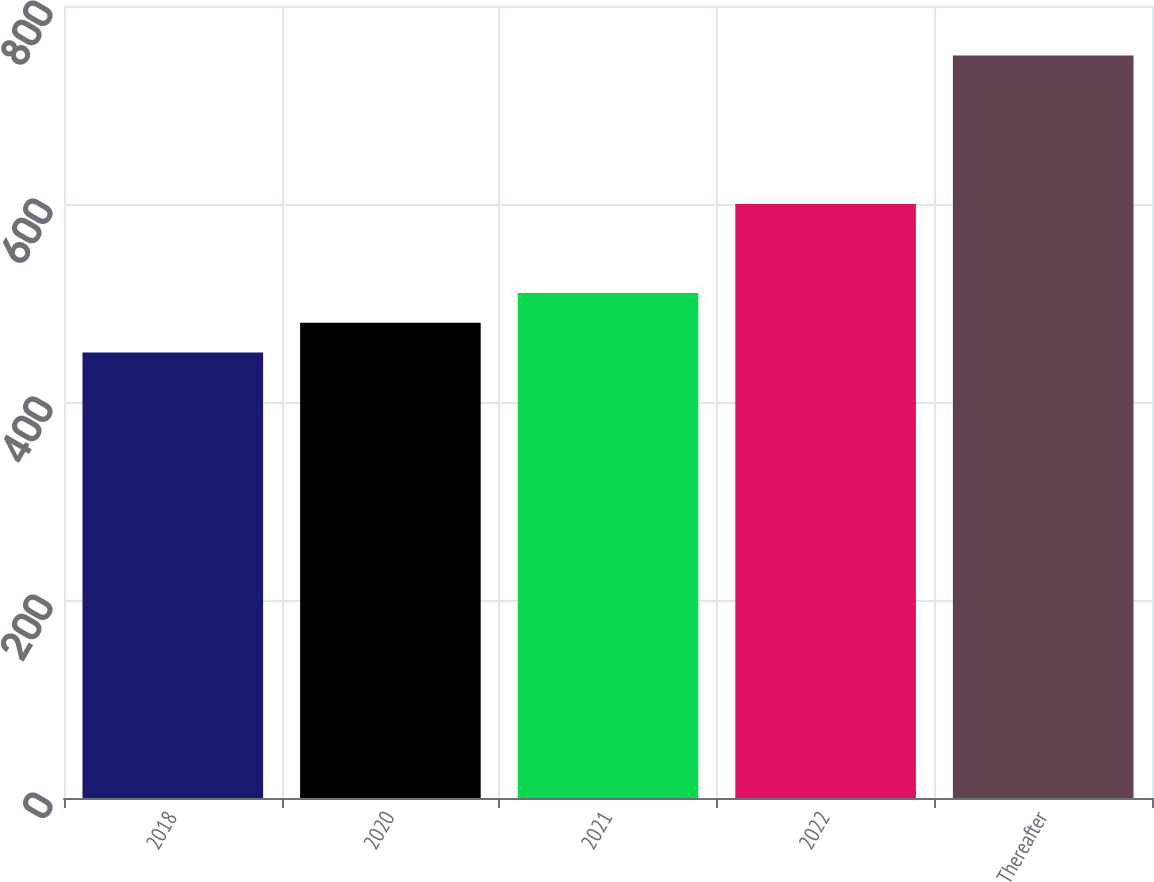<chart> <loc_0><loc_0><loc_500><loc_500><bar_chart><fcel>2018<fcel>2020<fcel>2021<fcel>2022<fcel>Thereafter<nl><fcel>450<fcel>480<fcel>510<fcel>600<fcel>750<nl></chart> 